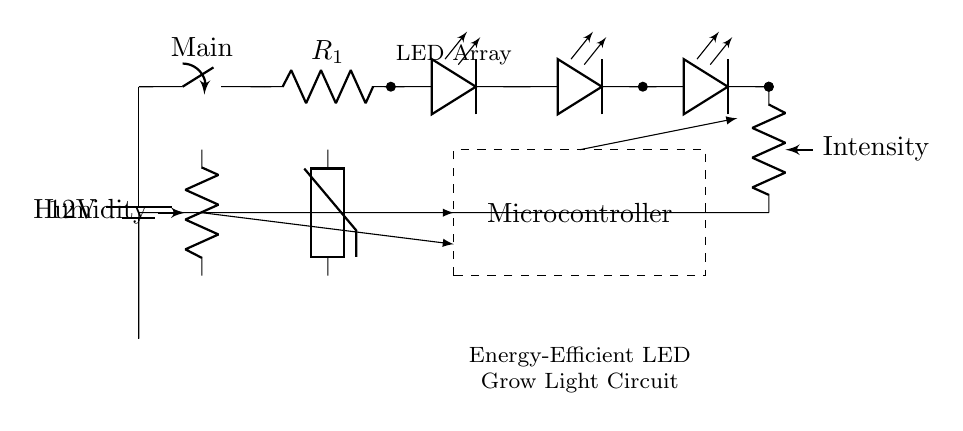What is the voltage of the power supply? The voltage of the power supply is given as 12V, which is represented by the battery symbol in the circuit.
Answer: 12V What type of light sources are used in this circuit? The light sources in this circuit are LED arrays, indicated by the leDo symbols in the diagram.
Answer: LED arrays What component is used to control light intensity? The component used to control the light intensity is a potentiometer, as indicated by the label "Intensity" in the circuit.
Answer: Potentiometer What are the two types of sensors integrated into the circuit? The sensors integrated into the circuit are a thermistor for temperature and a potentiometer labeled "Humidity" for humidity sensing, which can be seen in their respective places in the circuit.
Answer: Thermistor and Potentiometer How does the intensity control adjust the light output? The intensity control adjusts the light output by varying the resistance through the potentiometer, which modifies the current flowing through the LED array, thereby altering brightness. This is shown by the connection from the potentiometer to the LED array.
Answer: By varying resistance Which component provides a control signal to the potentiometer? The component providing a control signal to the potentiometer is the microcontroller, which is represented by the dashed rectangle in the circuit.
Answer: Microcontroller 